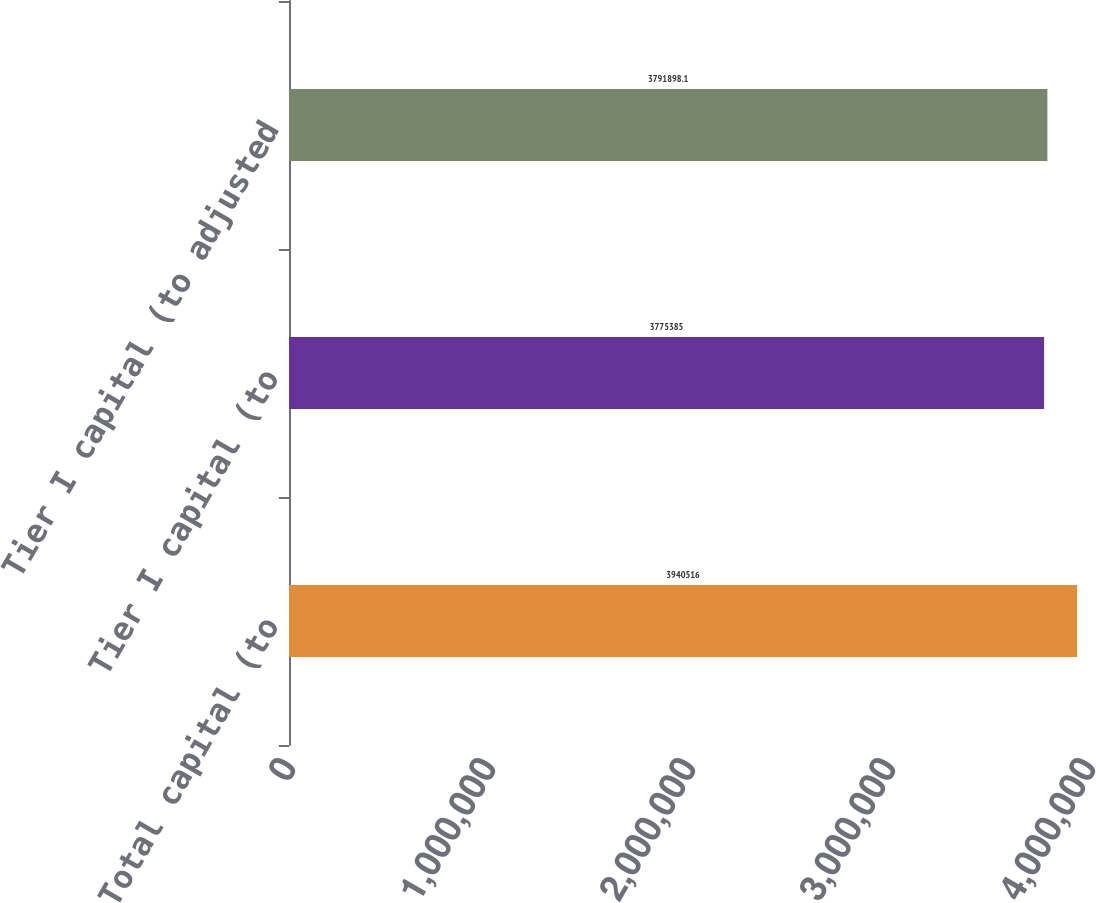<chart> <loc_0><loc_0><loc_500><loc_500><bar_chart><fcel>Total capital (to<fcel>Tier I capital (to<fcel>Tier I capital (to adjusted<nl><fcel>3.94052e+06<fcel>3.77538e+06<fcel>3.7919e+06<nl></chart> 